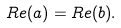<formula> <loc_0><loc_0><loc_500><loc_500>R e ( a ) = R e ( b ) .</formula> 